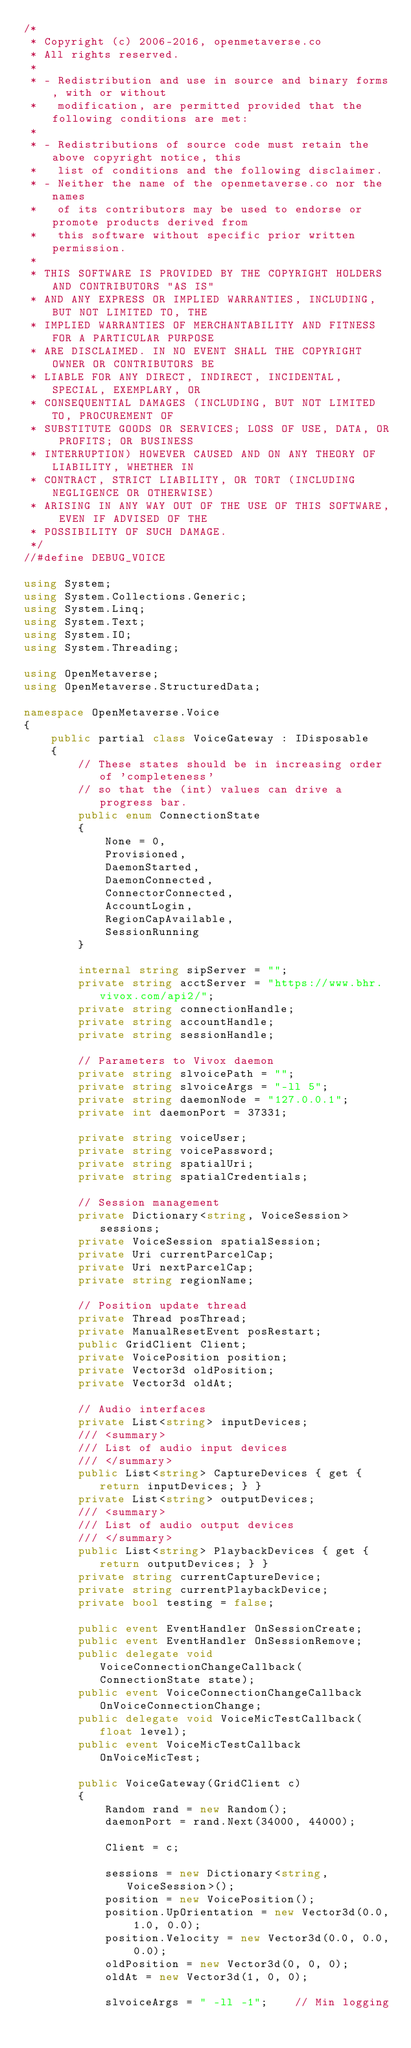Convert code to text. <code><loc_0><loc_0><loc_500><loc_500><_C#_>/*
 * Copyright (c) 2006-2016, openmetaverse.co
 * All rights reserved.
 *
 * - Redistribution and use in source and binary forms, with or without
 *   modification, are permitted provided that the following conditions are met:
 *
 * - Redistributions of source code must retain the above copyright notice, this
 *   list of conditions and the following disclaimer.
 * - Neither the name of the openmetaverse.co nor the names
 *   of its contributors may be used to endorse or promote products derived from
 *   this software without specific prior written permission.
 *
 * THIS SOFTWARE IS PROVIDED BY THE COPYRIGHT HOLDERS AND CONTRIBUTORS "AS IS"
 * AND ANY EXPRESS OR IMPLIED WARRANTIES, INCLUDING, BUT NOT LIMITED TO, THE
 * IMPLIED WARRANTIES OF MERCHANTABILITY AND FITNESS FOR A PARTICULAR PURPOSE
 * ARE DISCLAIMED. IN NO EVENT SHALL THE COPYRIGHT OWNER OR CONTRIBUTORS BE
 * LIABLE FOR ANY DIRECT, INDIRECT, INCIDENTAL, SPECIAL, EXEMPLARY, OR
 * CONSEQUENTIAL DAMAGES (INCLUDING, BUT NOT LIMITED TO, PROCUREMENT OF
 * SUBSTITUTE GOODS OR SERVICES; LOSS OF USE, DATA, OR PROFITS; OR BUSINESS
 * INTERRUPTION) HOWEVER CAUSED AND ON ANY THEORY OF LIABILITY, WHETHER IN
 * CONTRACT, STRICT LIABILITY, OR TORT (INCLUDING NEGLIGENCE OR OTHERWISE)
 * ARISING IN ANY WAY OUT OF THE USE OF THIS SOFTWARE, EVEN IF ADVISED OF THE
 * POSSIBILITY OF SUCH DAMAGE.
 */
//#define DEBUG_VOICE

using System;
using System.Collections.Generic;
using System.Linq;
using System.Text;
using System.IO;
using System.Threading;

using OpenMetaverse;
using OpenMetaverse.StructuredData;

namespace OpenMetaverse.Voice
{
    public partial class VoiceGateway : IDisposable
    {
        // These states should be in increasing order of 'completeness'
        // so that the (int) values can drive a progress bar.
        public enum ConnectionState
        {
            None = 0,
            Provisioned,
            DaemonStarted,
            DaemonConnected,
            ConnectorConnected,
            AccountLogin,
            RegionCapAvailable,
            SessionRunning
        }

        internal string sipServer = "";
        private string acctServer = "https://www.bhr.vivox.com/api2/";
        private string connectionHandle;
        private string accountHandle;
        private string sessionHandle;

        // Parameters to Vivox daemon
        private string slvoicePath = "";
        private string slvoiceArgs = "-ll 5";
        private string daemonNode = "127.0.0.1";
        private int daemonPort = 37331;

        private string voiceUser;
        private string voicePassword;
        private string spatialUri;
        private string spatialCredentials;

        // Session management
        private Dictionary<string, VoiceSession> sessions;
        private VoiceSession spatialSession;
        private Uri currentParcelCap;
        private Uri nextParcelCap;
        private string regionName;

        // Position update thread
        private Thread posThread;
        private ManualResetEvent posRestart;
        public GridClient Client;
        private VoicePosition position;
        private Vector3d oldPosition;
        private Vector3d oldAt;

        // Audio interfaces
        private List<string> inputDevices;
        /// <summary>
        /// List of audio input devices
        /// </summary>
        public List<string> CaptureDevices { get { return inputDevices; } }
        private List<string> outputDevices;
        /// <summary>
        /// List of audio output devices
        /// </summary>
        public List<string> PlaybackDevices { get { return outputDevices; } }
        private string currentCaptureDevice;
        private string currentPlaybackDevice;
        private bool testing = false;

        public event EventHandler OnSessionCreate;
        public event EventHandler OnSessionRemove;
        public delegate void VoiceConnectionChangeCallback(ConnectionState state);
        public event VoiceConnectionChangeCallback OnVoiceConnectionChange;
        public delegate void VoiceMicTestCallback(float level);
        public event VoiceMicTestCallback OnVoiceMicTest;

        public VoiceGateway(GridClient c)
        {
            Random rand = new Random();
            daemonPort = rand.Next(34000, 44000);

            Client = c;

            sessions = new Dictionary<string, VoiceSession>();
            position = new VoicePosition();
            position.UpOrientation = new Vector3d(0.0, 1.0, 0.0);
            position.Velocity = new Vector3d(0.0, 0.0, 0.0);
            oldPosition = new Vector3d(0, 0, 0);
            oldAt = new Vector3d(1, 0, 0);

            slvoiceArgs = " -ll -1";    // Min logging</code> 